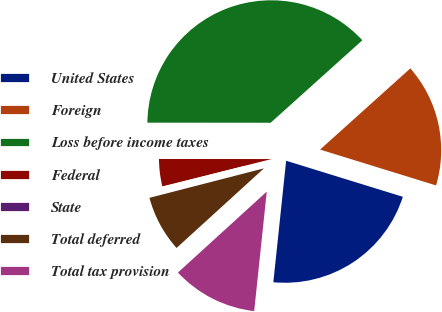Convert chart to OTSL. <chart><loc_0><loc_0><loc_500><loc_500><pie_chart><fcel>United States<fcel>Foreign<fcel>Loss before income taxes<fcel>Federal<fcel>State<fcel>Total deferred<fcel>Total tax provision<nl><fcel>21.9%<fcel>16.43%<fcel>38.33%<fcel>3.92%<fcel>0.1%<fcel>7.75%<fcel>11.57%<nl></chart> 